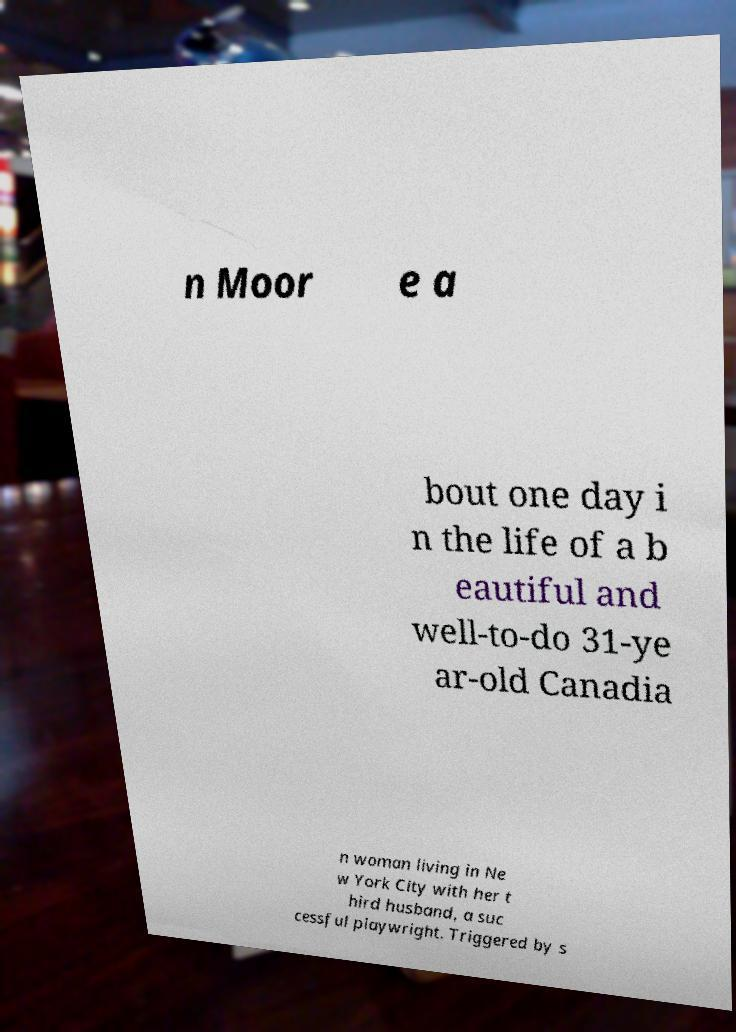There's text embedded in this image that I need extracted. Can you transcribe it verbatim? n Moor e a bout one day i n the life of a b eautiful and well-to-do 31-ye ar-old Canadia n woman living in Ne w York City with her t hird husband, a suc cessful playwright. Triggered by s 